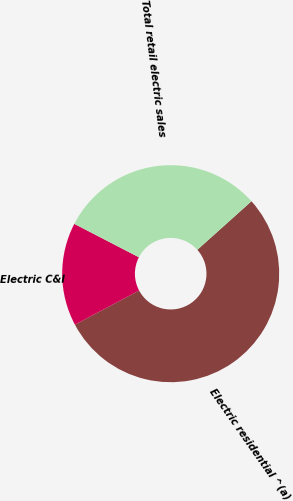Convert chart. <chart><loc_0><loc_0><loc_500><loc_500><pie_chart><fcel>Electric residential ^(a)<fcel>Electric C&I<fcel>Total retail electric sales<nl><fcel>53.85%<fcel>15.38%<fcel>30.77%<nl></chart> 